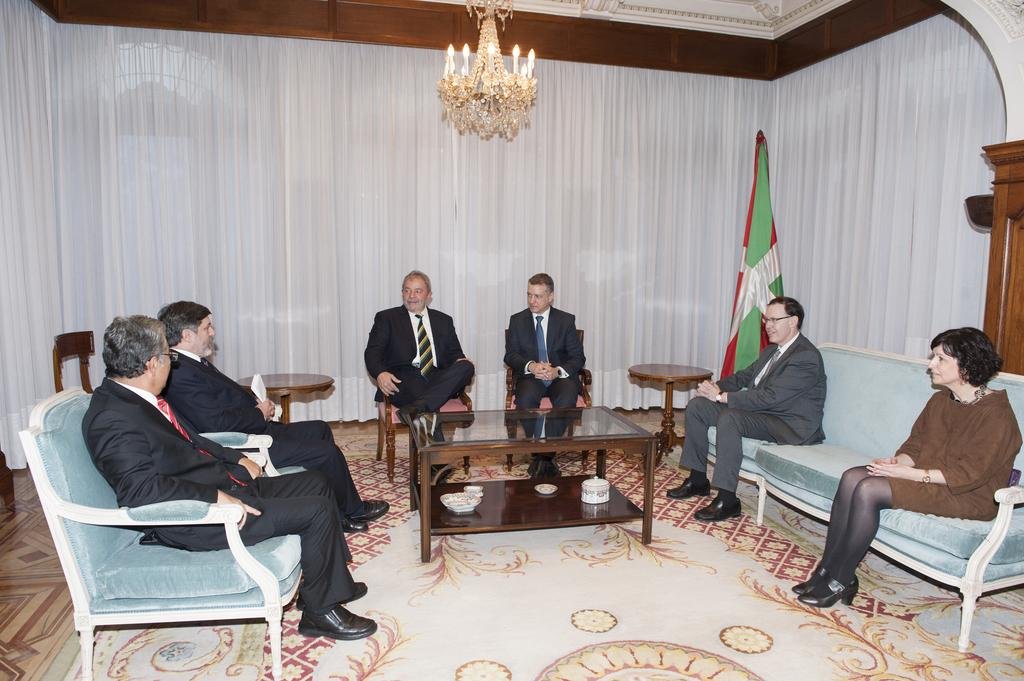What type of material is the cloth in the image made of? The cloth in the image is white, but the material is not specified. What type of lighting fixture is in the image? There is a chandelier in the image. What type of decoration or symbol is in the image? There is a flag in the image. What type of seating is available in the image? There are people sitting on benches and chairs in the image. What type of furniture is in the image? There is a table in the image. How many woolly dinosaurs can be seen grazing on the grass in the image? There are no woolly dinosaurs present in the image. What type of lock is used to secure the chandelier in the image? There is no lock present in the image, and the chandelier is not secured. 